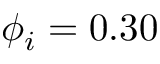<formula> <loc_0><loc_0><loc_500><loc_500>\phi _ { i } = 0 . 3 0</formula> 